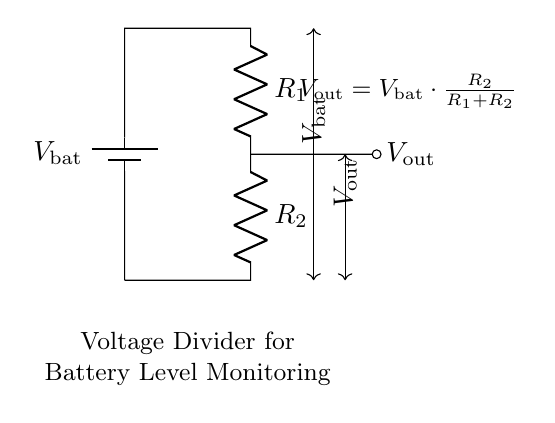What is the main purpose of this circuit? The main purpose of this circuit is to monitor battery levels in portable financial devices by producing a measurable output voltage proportional to the battery voltage.
Answer: Battery level monitoring What does V out represent in this circuit? V out represents the output voltage that is taken from the voltage divider, which can be used to assess the voltage of the battery.
Answer: Output voltage What does the formula shown in the circuit represent? The formula shows the relationship between the output voltage and the battery voltage, factoring in the two resistor values. The output voltage is calculated based on the voltage division rule.
Answer: Voltage division Which two resistors are present in the circuit? The two resistors present in the circuit are R1 and R2, which together form the voltage divider network.
Answer: R1 and R2 How does changing R2 affect V out? Increasing R2 will increase V out, as a larger denominator in the voltage division formula results in a higher output voltage for the same battery voltage. Conversely, decreasing R2 will lower V out.
Answer: Increases V out What happens if the battery voltage increases? If the battery voltage increases, V out will also increase proportionally, as the output voltage is directly affected by the change in battery voltage through the voltage divider formula.
Answer: V out increases 